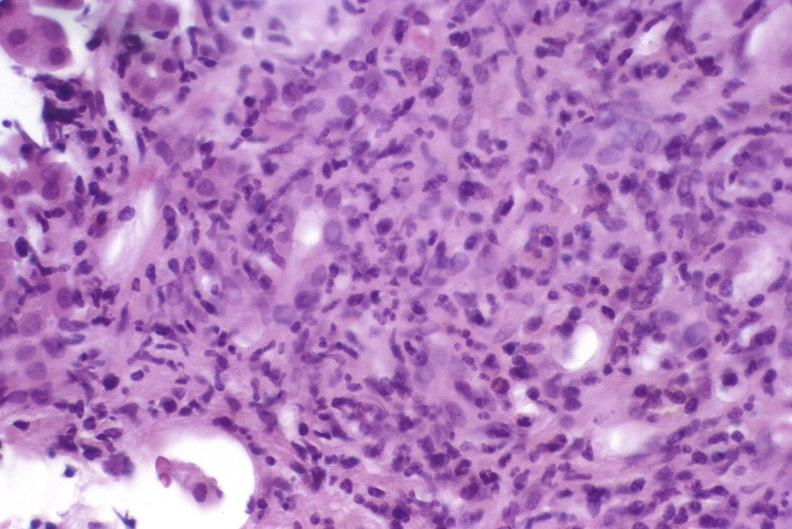s metastatic carcinoma prostate present?
Answer the question using a single word or phrase. No 